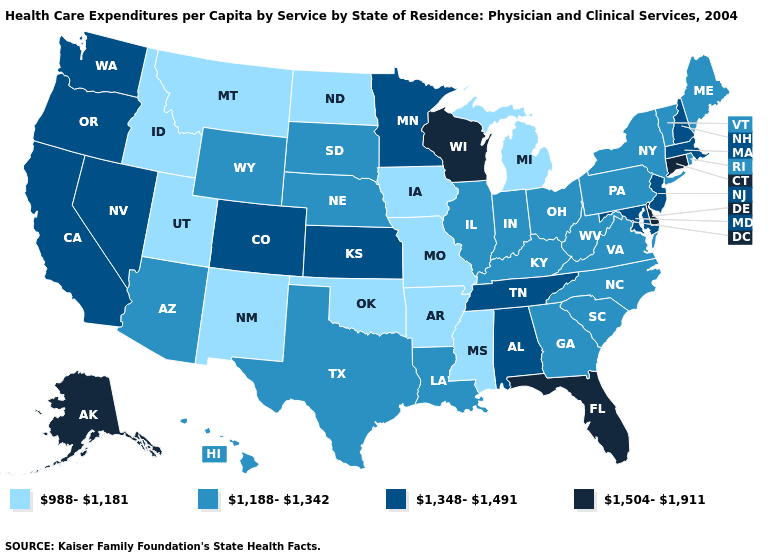What is the value of Indiana?
Answer briefly. 1,188-1,342. What is the highest value in the West ?
Give a very brief answer. 1,504-1,911. What is the value of Florida?
Keep it brief. 1,504-1,911. Name the states that have a value in the range 1,504-1,911?
Write a very short answer. Alaska, Connecticut, Delaware, Florida, Wisconsin. What is the highest value in states that border Tennessee?
Be succinct. 1,348-1,491. What is the highest value in the USA?
Quick response, please. 1,504-1,911. What is the lowest value in the West?
Keep it brief. 988-1,181. Name the states that have a value in the range 1,348-1,491?
Quick response, please. Alabama, California, Colorado, Kansas, Maryland, Massachusetts, Minnesota, Nevada, New Hampshire, New Jersey, Oregon, Tennessee, Washington. Name the states that have a value in the range 988-1,181?
Answer briefly. Arkansas, Idaho, Iowa, Michigan, Mississippi, Missouri, Montana, New Mexico, North Dakota, Oklahoma, Utah. Which states have the lowest value in the MidWest?
Concise answer only. Iowa, Michigan, Missouri, North Dakota. Name the states that have a value in the range 1,504-1,911?
Keep it brief. Alaska, Connecticut, Delaware, Florida, Wisconsin. Does the map have missing data?
Be succinct. No. Name the states that have a value in the range 1,188-1,342?
Be succinct. Arizona, Georgia, Hawaii, Illinois, Indiana, Kentucky, Louisiana, Maine, Nebraska, New York, North Carolina, Ohio, Pennsylvania, Rhode Island, South Carolina, South Dakota, Texas, Vermont, Virginia, West Virginia, Wyoming. What is the highest value in the Northeast ?
Keep it brief. 1,504-1,911. Name the states that have a value in the range 1,504-1,911?
Answer briefly. Alaska, Connecticut, Delaware, Florida, Wisconsin. 